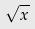<formula> <loc_0><loc_0><loc_500><loc_500>\sqrt { x }</formula> 